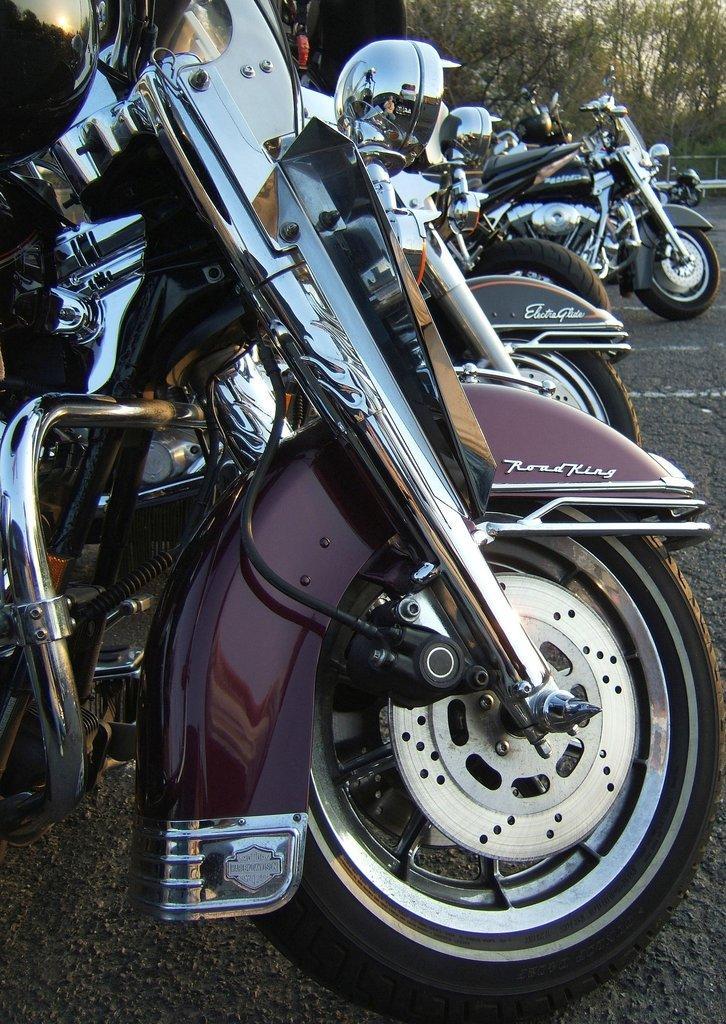Please provide a concise description of this image. There are bikes on the road. In the background there are trees, an object and the sky. 